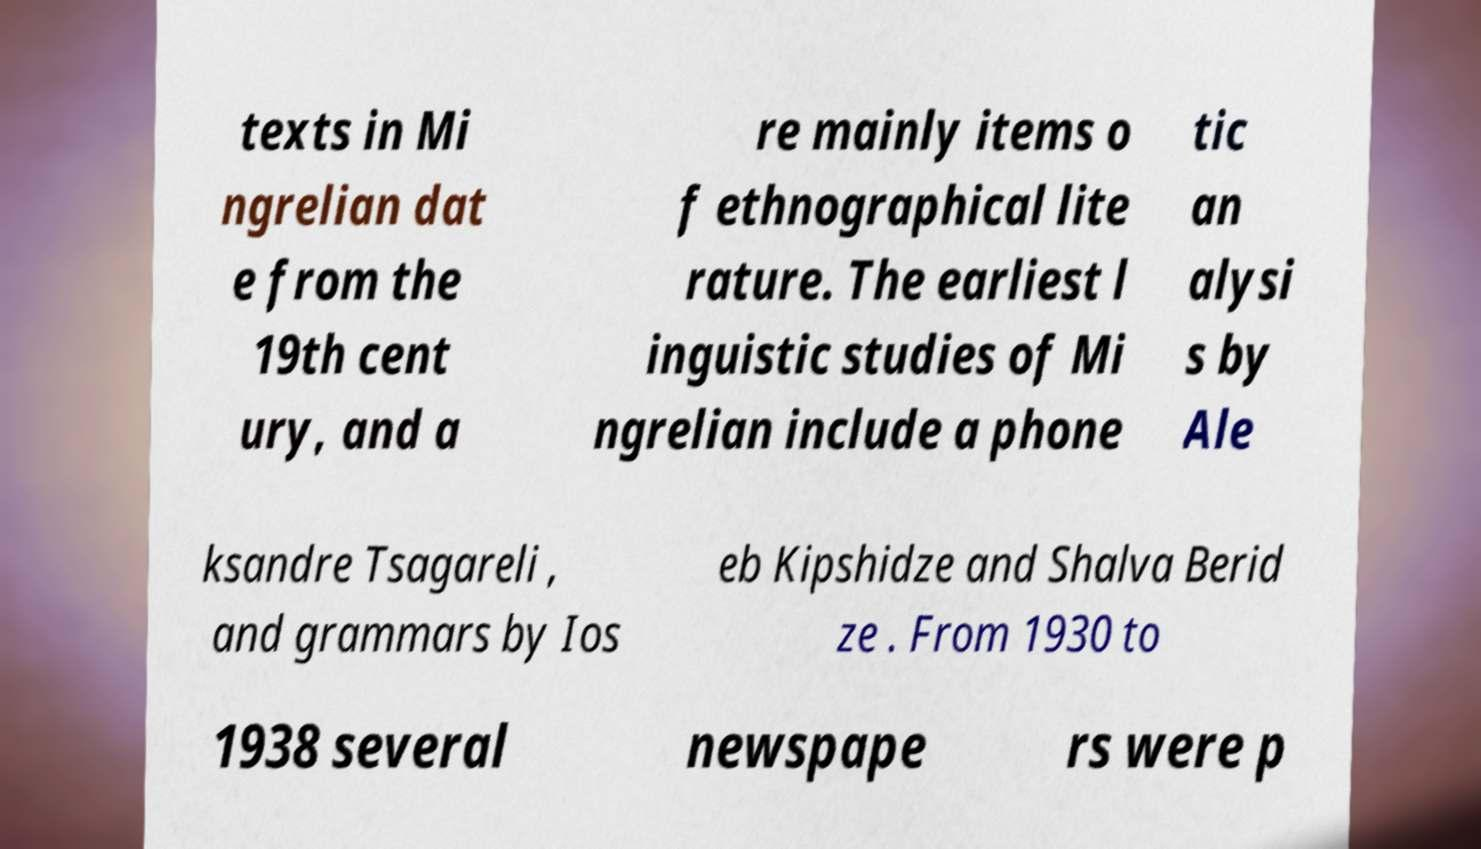Please read and relay the text visible in this image. What does it say? texts in Mi ngrelian dat e from the 19th cent ury, and a re mainly items o f ethnographical lite rature. The earliest l inguistic studies of Mi ngrelian include a phone tic an alysi s by Ale ksandre Tsagareli , and grammars by Ios eb Kipshidze and Shalva Berid ze . From 1930 to 1938 several newspape rs were p 